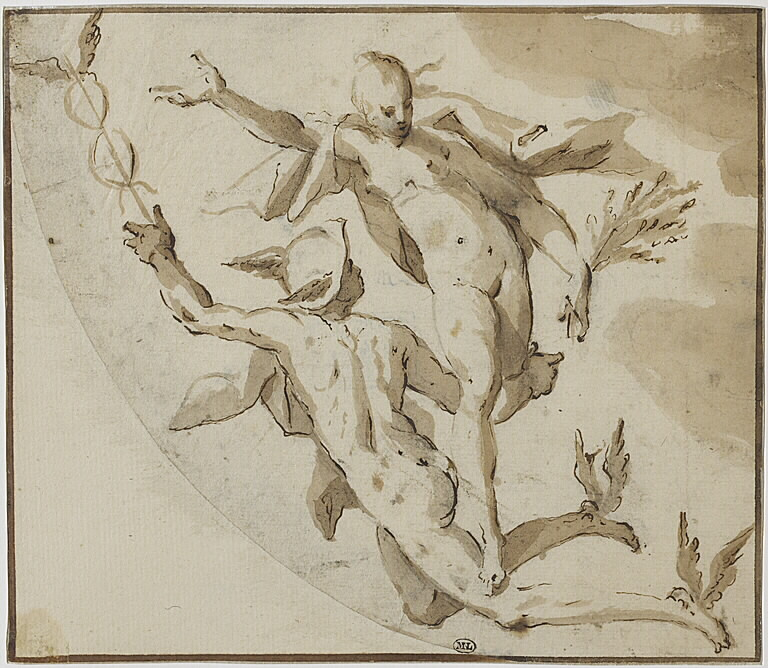What's happening in the scene? The image depicts an engaging scene featuring two figures, a male and a female, set within a circular frame. The male figure is presented in an energetic pose, lifting the female figure, which conveys a sense of dynamic motion. The artwork's sketchy style, with delicate washes of gray and brown, adds depth and texture to the composition. This style is reminiscent of the Baroque or Rococo periods, characterized by their emphasis on movement, drama, and theatrical flair. The artwork likely represents a preliminary study or sketch for a more significant piece, reflecting common practices in these artistic eras. The focus on the figures suggests an underlying narrative, inviting viewers to ponder the story and emotions conveyed through their interaction. 